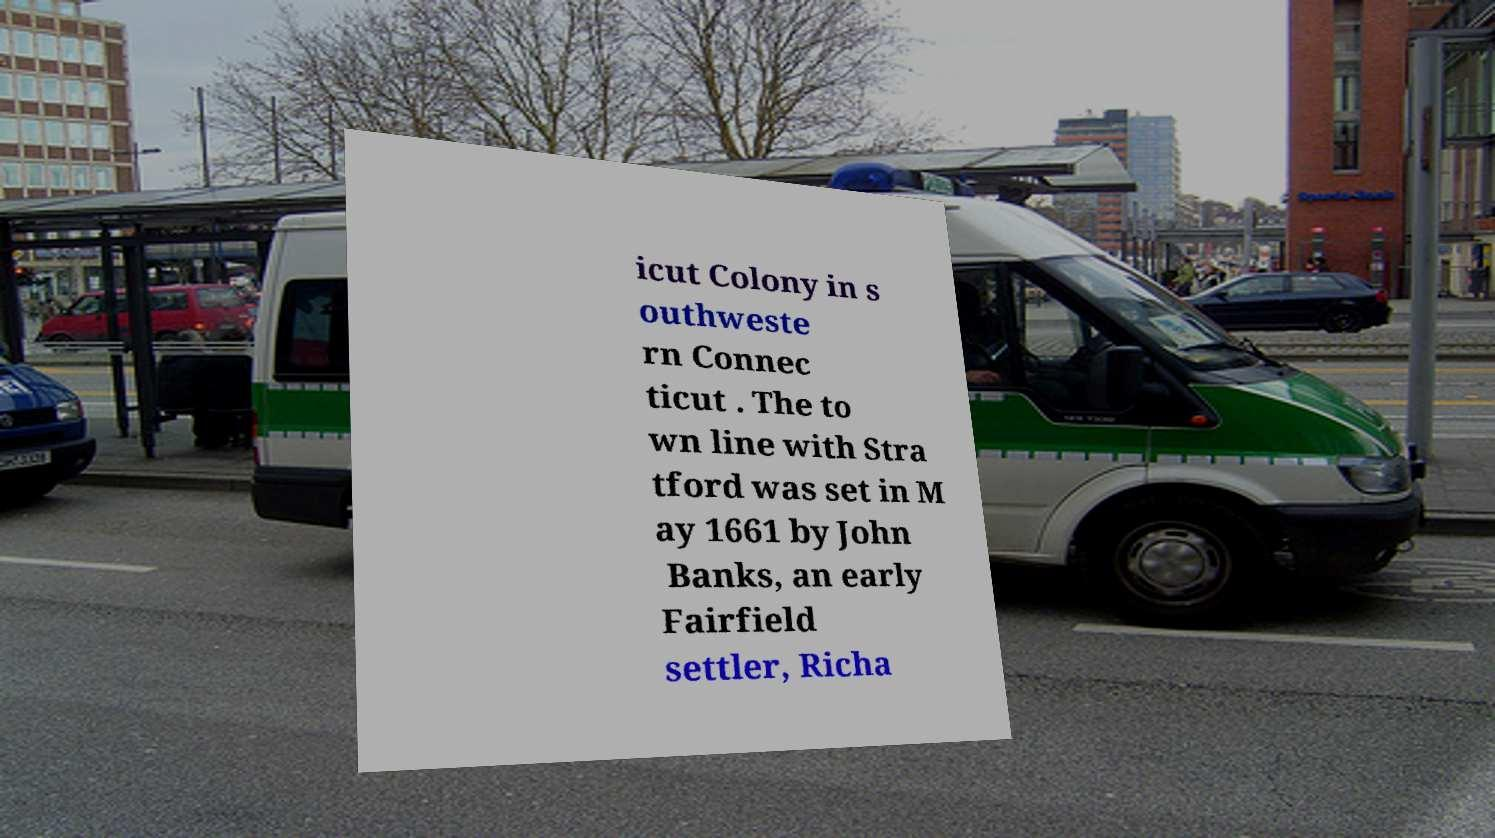Can you accurately transcribe the text from the provided image for me? icut Colony in s outhweste rn Connec ticut . The to wn line with Stra tford was set in M ay 1661 by John Banks, an early Fairfield settler, Richa 